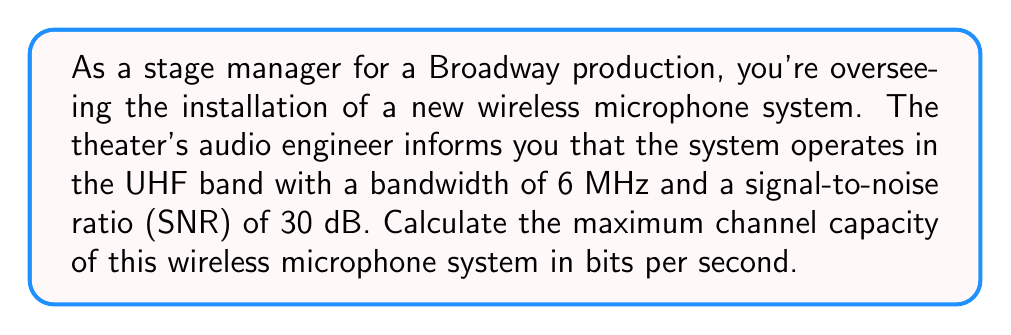What is the answer to this math problem? To solve this problem, we'll use the Shannon-Hartley theorem, which gives the channel capacity for a communications channel subject to Gaussian noise. The theorem is expressed as:

$$C = B \log_2(1 + SNR)$$

Where:
$C$ = Channel capacity in bits per second (bps)
$B$ = Bandwidth in Hertz (Hz)
$SNR$ = Signal-to-noise ratio (linear, not dB)

Given:
- Bandwidth (B) = 6 MHz = 6,000,000 Hz
- SNR = 30 dB

Step 1: Convert SNR from dB to linear scale
SNR in linear scale = $10^{(SNR_{dB}/10)}$
$SNR_{linear} = 10^{(30/10)} = 1000$

Step 2: Apply the Shannon-Hartley theorem
$$\begin{align}
C &= B \log_2(1 + SNR) \\
&= 6,000,000 \log_2(1 + 1000) \\
&= 6,000,000 \log_2(1001)
\end{align}$$

Step 3: Calculate the result
Using a calculator or computer:
$$C = 6,000,000 \times 9.96578428466209 \approx 59,794,705.71 \text{ bps}$$

Therefore, the maximum channel capacity is approximately 59.79 Mbps.
Answer: 59.79 Mbps 